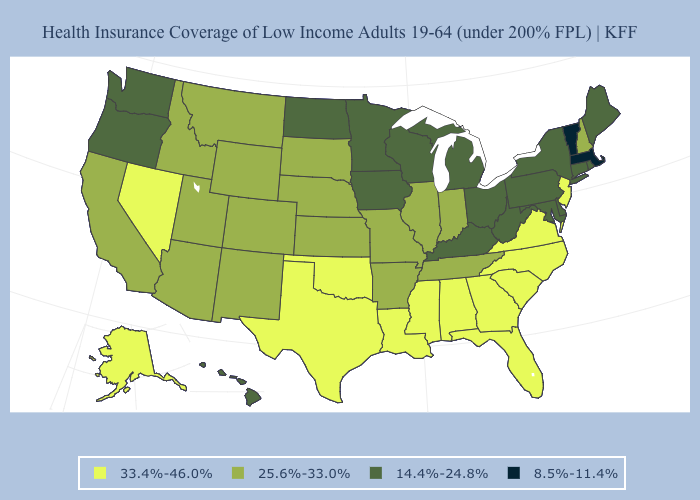What is the value of New York?
Keep it brief. 14.4%-24.8%. Among the states that border Utah , does Nevada have the highest value?
Short answer required. Yes. Among the states that border Pennsylvania , does New Jersey have the lowest value?
Give a very brief answer. No. What is the value of New Hampshire?
Concise answer only. 25.6%-33.0%. Name the states that have a value in the range 33.4%-46.0%?
Write a very short answer. Alabama, Alaska, Florida, Georgia, Louisiana, Mississippi, Nevada, New Jersey, North Carolina, Oklahoma, South Carolina, Texas, Virginia. Does the first symbol in the legend represent the smallest category?
Keep it brief. No. What is the value of Oklahoma?
Short answer required. 33.4%-46.0%. What is the highest value in states that border South Dakota?
Answer briefly. 25.6%-33.0%. What is the value of Virginia?
Write a very short answer. 33.4%-46.0%. What is the highest value in states that border California?
Answer briefly. 33.4%-46.0%. Which states have the lowest value in the South?
Answer briefly. Delaware, Kentucky, Maryland, West Virginia. Which states hav the highest value in the West?
Answer briefly. Alaska, Nevada. What is the highest value in the USA?
Be succinct. 33.4%-46.0%. Name the states that have a value in the range 25.6%-33.0%?
Answer briefly. Arizona, Arkansas, California, Colorado, Idaho, Illinois, Indiana, Kansas, Missouri, Montana, Nebraska, New Hampshire, New Mexico, South Dakota, Tennessee, Utah, Wyoming. Does California have the highest value in the USA?
Quick response, please. No. 